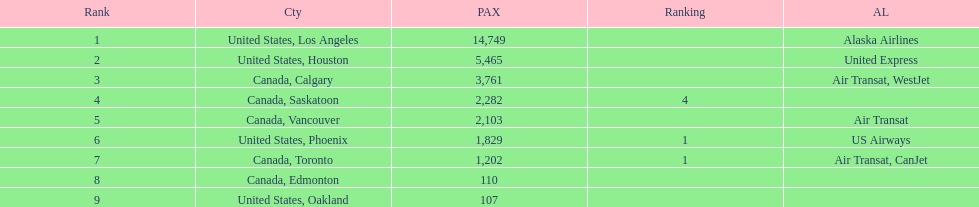What was the number of passengers in phoenix arizona? 1,829. 